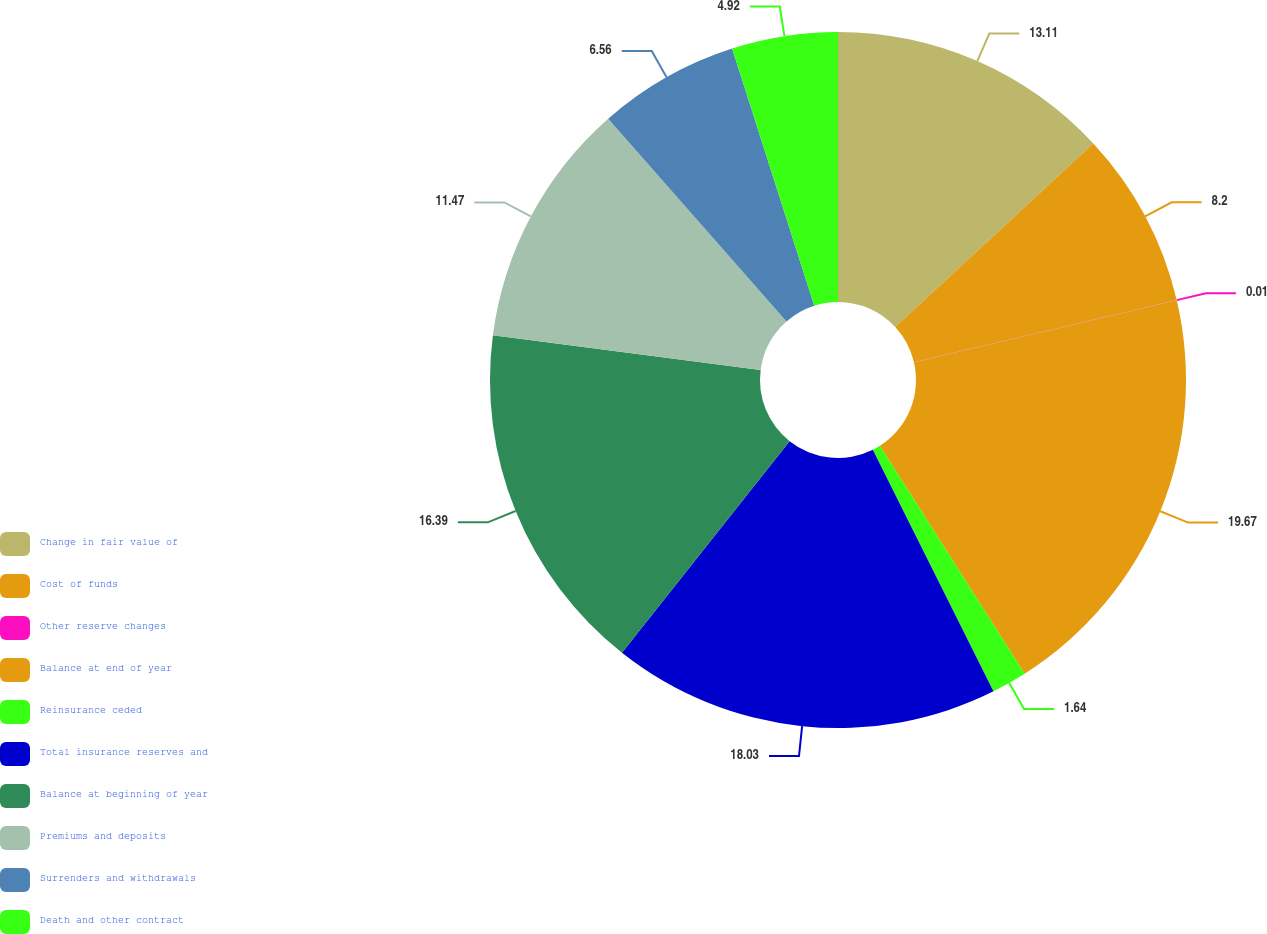<chart> <loc_0><loc_0><loc_500><loc_500><pie_chart><fcel>Change in fair value of<fcel>Cost of funds<fcel>Other reserve changes<fcel>Balance at end of year<fcel>Reinsurance ceded<fcel>Total insurance reserves and<fcel>Balance at beginning of year<fcel>Premiums and deposits<fcel>Surrenders and withdrawals<fcel>Death and other contract<nl><fcel>13.11%<fcel>8.2%<fcel>0.01%<fcel>19.67%<fcel>1.64%<fcel>18.03%<fcel>16.39%<fcel>11.47%<fcel>6.56%<fcel>4.92%<nl></chart> 